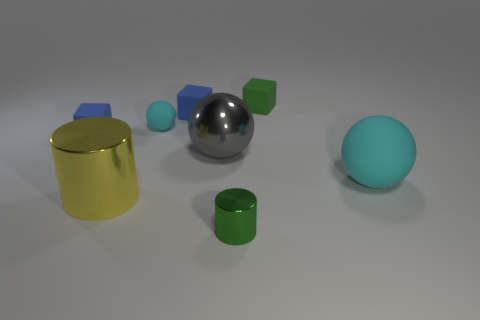What number of big objects are either metal things or blue cubes?
Keep it short and to the point. 2. How many large objects are behind the yellow metal thing and to the left of the green rubber cube?
Ensure brevity in your answer.  1. Is the number of large cylinders greater than the number of big green rubber cylinders?
Your answer should be compact. Yes. What number of other things are there of the same shape as the yellow object?
Your answer should be compact. 1. Do the tiny sphere and the tiny cylinder have the same color?
Give a very brief answer. No. There is a cube that is to the left of the gray sphere and on the right side of the big yellow cylinder; what is its material?
Ensure brevity in your answer.  Rubber. What size is the green metallic cylinder?
Your answer should be compact. Small. What number of large metallic things are behind the large object right of the large sphere that is left of the small green cylinder?
Your answer should be compact. 1. There is a small green metallic thing in front of the cyan thing to the left of the big metal sphere; what is its shape?
Give a very brief answer. Cylinder. What is the size of the other rubber thing that is the same shape as the small cyan thing?
Provide a succinct answer. Large. 